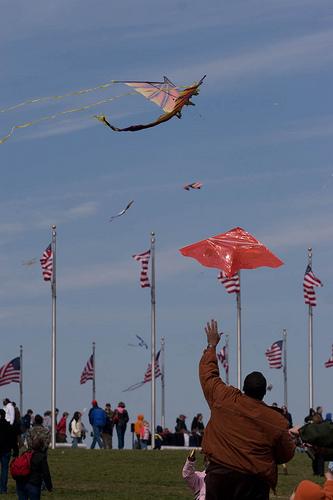Are the people under an umbrella?
Concise answer only. No. What countries flags are on the poles?
Short answer required. Usa. What nation do the flags shown represent?
Answer briefly. United states. How many flags are shown?
Concise answer only. 9. What activity is the man doing?
Quick response, please. Flying kite. How many American flags are visible in the sky?
Write a very short answer. 10. 